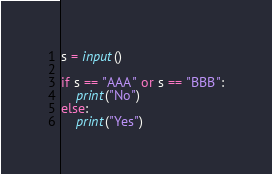<code> <loc_0><loc_0><loc_500><loc_500><_Python_>s = input()

if s == "AAA" or s == "BBB":
    print("No")
else:
    print("Yes")

</code> 